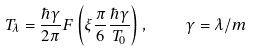Convert formula to latex. <formula><loc_0><loc_0><loc_500><loc_500>T _ { \lambda } = \frac { \hbar { \gamma } } { 2 \pi } F \left ( \xi \frac { \pi } { 6 } \frac { \hbar { \gamma } } { T _ { 0 } } \right ) , \quad \gamma = \lambda / m</formula> 